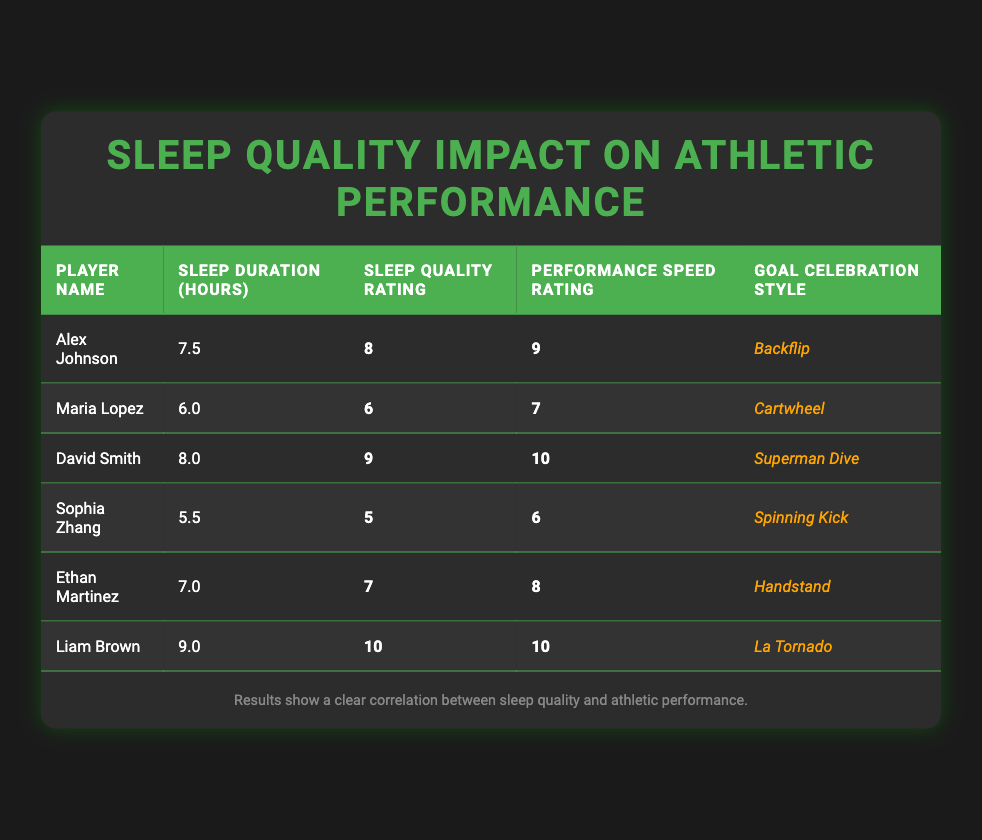What is the sleep duration of David Smith? In the table, locate the row for David Smith. The value in the Sleep Duration (hours) column is 8.0.
Answer: 8.0 Which player has the highest Performance Speed Rating? To find the highest Performance Speed Rating, compare the values in that column. Liam Brown and David Smith both have a rating of 10, which is the highest among all players.
Answer: Liam Brown and David Smith What is the average Sleep Quality Rating of all players? Add the Sleep Quality Ratings together: (8 + 6 + 9 + 5 + 7 + 10) = 45. There are 6 players, so the average is 45 / 6 = 7.5.
Answer: 7.5 Is it true that Sophia Zhang has a Sleep Quality Rating lower than 6? The Sleep Quality Rating for Sophia Zhang is 5, which is indeed lower than 6.
Answer: Yes What is the difference between the highest and lowest Sleep Duration among players? Identify the highest Sleep Duration (9.0 for Liam Brown) and the lowest (5.5 for Sophia Zhang). The difference is 9.0 - 5.5 = 3.5.
Answer: 3.5 Which player has both the highest Sleep Quality Rating and the highest Performance Speed Rating? Examine the table: Liam Brown has a Sleep Quality Rating of 10 and a Performance Speed Rating of 10. He is the only player with both ratings at the highest level.
Answer: Liam Brown How many players have a Performance Speed Rating of 8 or higher? Count the players with Performance Speed Ratings of 8 or higher: Alex Johnson (9), David Smith (10), Liam Brown (10), and Ethan Martinez (8), totaling 4 players.
Answer: 4 Does Maria Lopez have a Goal Celebration Style of "Handstand"? Check Maria Lopez's row for her Goal Celebration Style, which is listed as "Cartwheel," not "Handstand."
Answer: No What is the median Sleep Quality Rating of the players? First, list the Sleep Quality Ratings: 5, 6, 7, 8, 9, 10. There are an even number of ratings (6), so the median is the average of the 3rd and 4th values: (7 + 8) / 2 = 7.5.
Answer: 7.5 